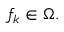<formula> <loc_0><loc_0><loc_500><loc_500>f _ { k } \in \Omega .</formula> 